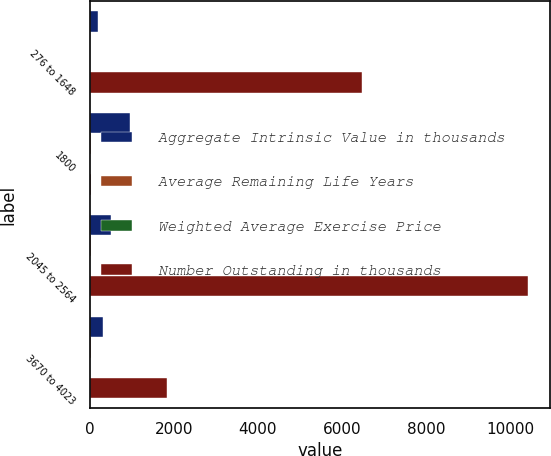Convert chart to OTSL. <chart><loc_0><loc_0><loc_500><loc_500><stacked_bar_chart><ecel><fcel>276 to 1648<fcel>1800<fcel>2045 to 2564<fcel>3670 to 4023<nl><fcel>Aggregate Intrinsic Value in thousands<fcel>204<fcel>961<fcel>509<fcel>312<nl><fcel>Average Remaining Life Years<fcel>11.95<fcel>18<fcel>23.23<fcel>37.88<nl><fcel>Weighted Average Exercise Price<fcel>3.2<fcel>3.86<fcel>4.32<fcel>7.88<nl><fcel>Number Outstanding in thousands<fcel>6481<fcel>37.88<fcel>10433<fcel>1825<nl></chart> 